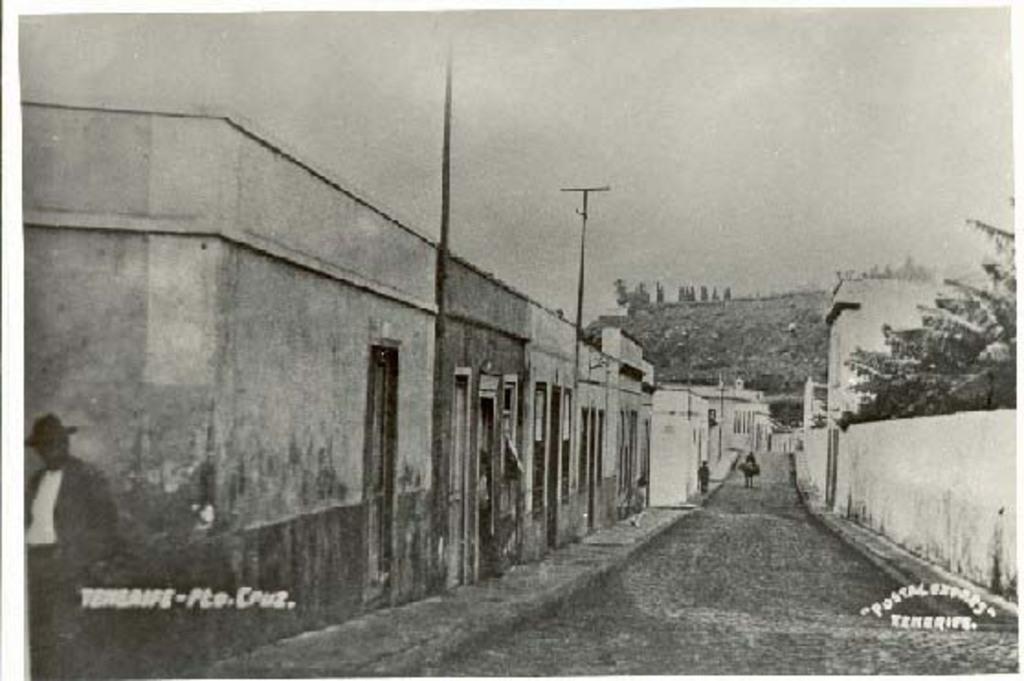In one or two sentences, can you explain what this image depicts? This picture describe about the old image. In the front there is a small lane with small houses and electric poles. On the right side we can see some trees and white color boundary wall. Behind we can see stone hill area. In the from bottom side we can see a man wearing black coat is walking on the street lane. 